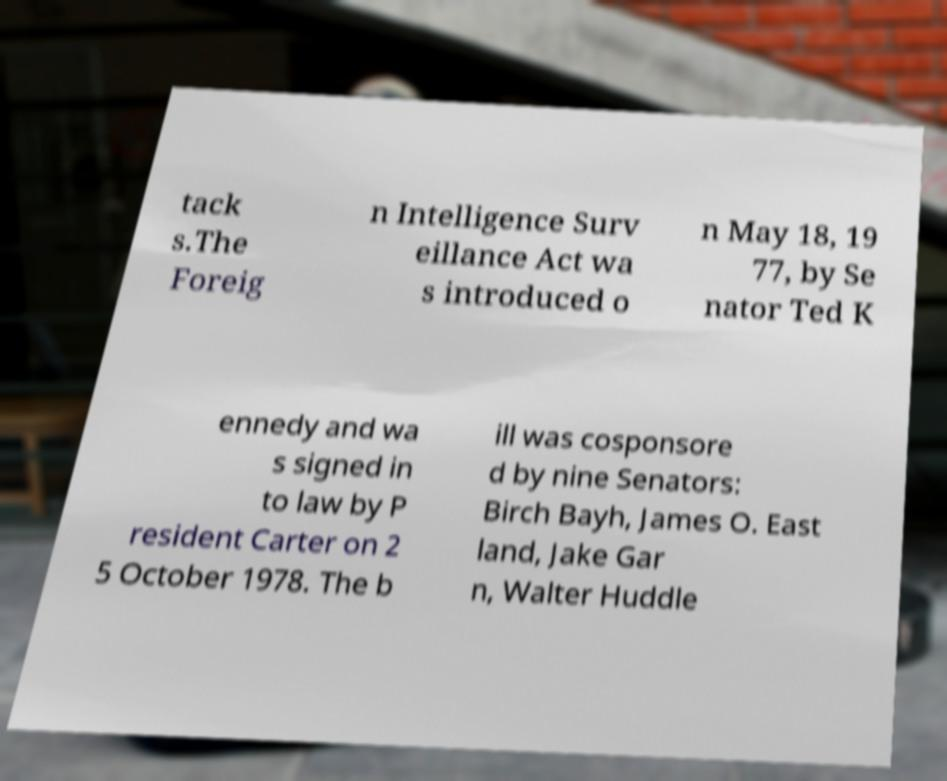For documentation purposes, I need the text within this image transcribed. Could you provide that? tack s.The Foreig n Intelligence Surv eillance Act wa s introduced o n May 18, 19 77, by Se nator Ted K ennedy and wa s signed in to law by P resident Carter on 2 5 October 1978. The b ill was cosponsore d by nine Senators: Birch Bayh, James O. East land, Jake Gar n, Walter Huddle 